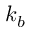Convert formula to latex. <formula><loc_0><loc_0><loc_500><loc_500>k _ { b }</formula> 